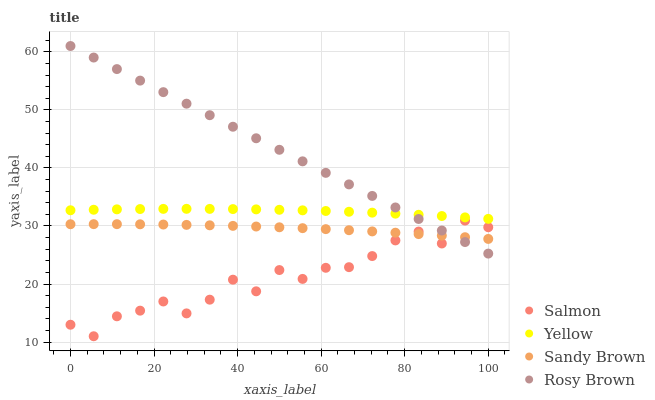Does Salmon have the minimum area under the curve?
Answer yes or no. Yes. Does Rosy Brown have the maximum area under the curve?
Answer yes or no. Yes. Does Rosy Brown have the minimum area under the curve?
Answer yes or no. No. Does Salmon have the maximum area under the curve?
Answer yes or no. No. Is Rosy Brown the smoothest?
Answer yes or no. Yes. Is Salmon the roughest?
Answer yes or no. Yes. Is Salmon the smoothest?
Answer yes or no. No. Is Rosy Brown the roughest?
Answer yes or no. No. Does Salmon have the lowest value?
Answer yes or no. Yes. Does Rosy Brown have the lowest value?
Answer yes or no. No. Does Rosy Brown have the highest value?
Answer yes or no. Yes. Does Salmon have the highest value?
Answer yes or no. No. Is Sandy Brown less than Yellow?
Answer yes or no. Yes. Is Yellow greater than Salmon?
Answer yes or no. Yes. Does Salmon intersect Rosy Brown?
Answer yes or no. Yes. Is Salmon less than Rosy Brown?
Answer yes or no. No. Is Salmon greater than Rosy Brown?
Answer yes or no. No. Does Sandy Brown intersect Yellow?
Answer yes or no. No. 